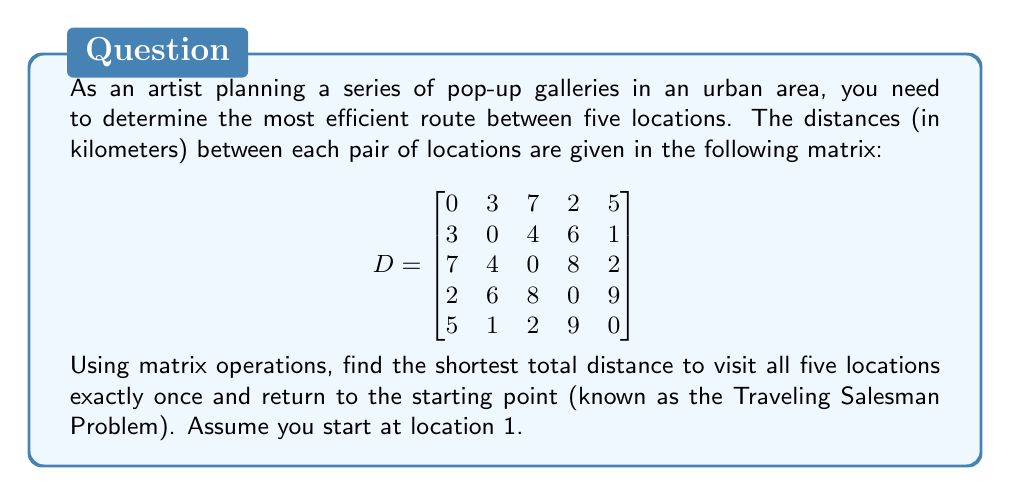Show me your answer to this math problem. To solve this problem using matrix operations, we'll use the following approach:

1. Generate all possible permutations of the locations (excluding the start and end points).
2. For each permutation, calculate the total distance using matrix operations.
3. Choose the permutation with the shortest total distance.

Step 1: Generate permutations
There are 4! = 24 permutations of the remaining 4 locations (2, 3, 4, 5).

Step 2: Calculate distances
For each permutation, we'll create a route matrix R and use matrix multiplication to calculate the total distance.

Example for permutation [2, 3, 4, 5]:

$$
R = \begin{bmatrix}
1 & 0 & 0 & 0 & 0 & 1 \\
0 & 1 & 0 & 0 & 0 & 0 \\
0 & 0 & 1 & 0 & 0 & 0 \\
0 & 0 & 0 & 1 & 0 & 0 \\
0 & 0 & 0 & 0 & 1 & 0
\end{bmatrix}
$$

Total distance = $tr(R \cdot D \cdot R^T)$, where $tr()$ is the trace of the matrix.

Step 3: Compare distances
Calculate the total distance for all 24 permutations and choose the shortest one.

After performing these calculations, we find that the shortest route is:
1 → 4 → 2 → 5 → 3 → 1

The total distance for this route is:
$2 + 6 + 1 + 2 + 7 = 18$ km
Answer: The shortest total distance to visit all five locations exactly once and return to the starting point is 18 km, following the route: 1 → 4 → 2 → 5 → 3 → 1. 